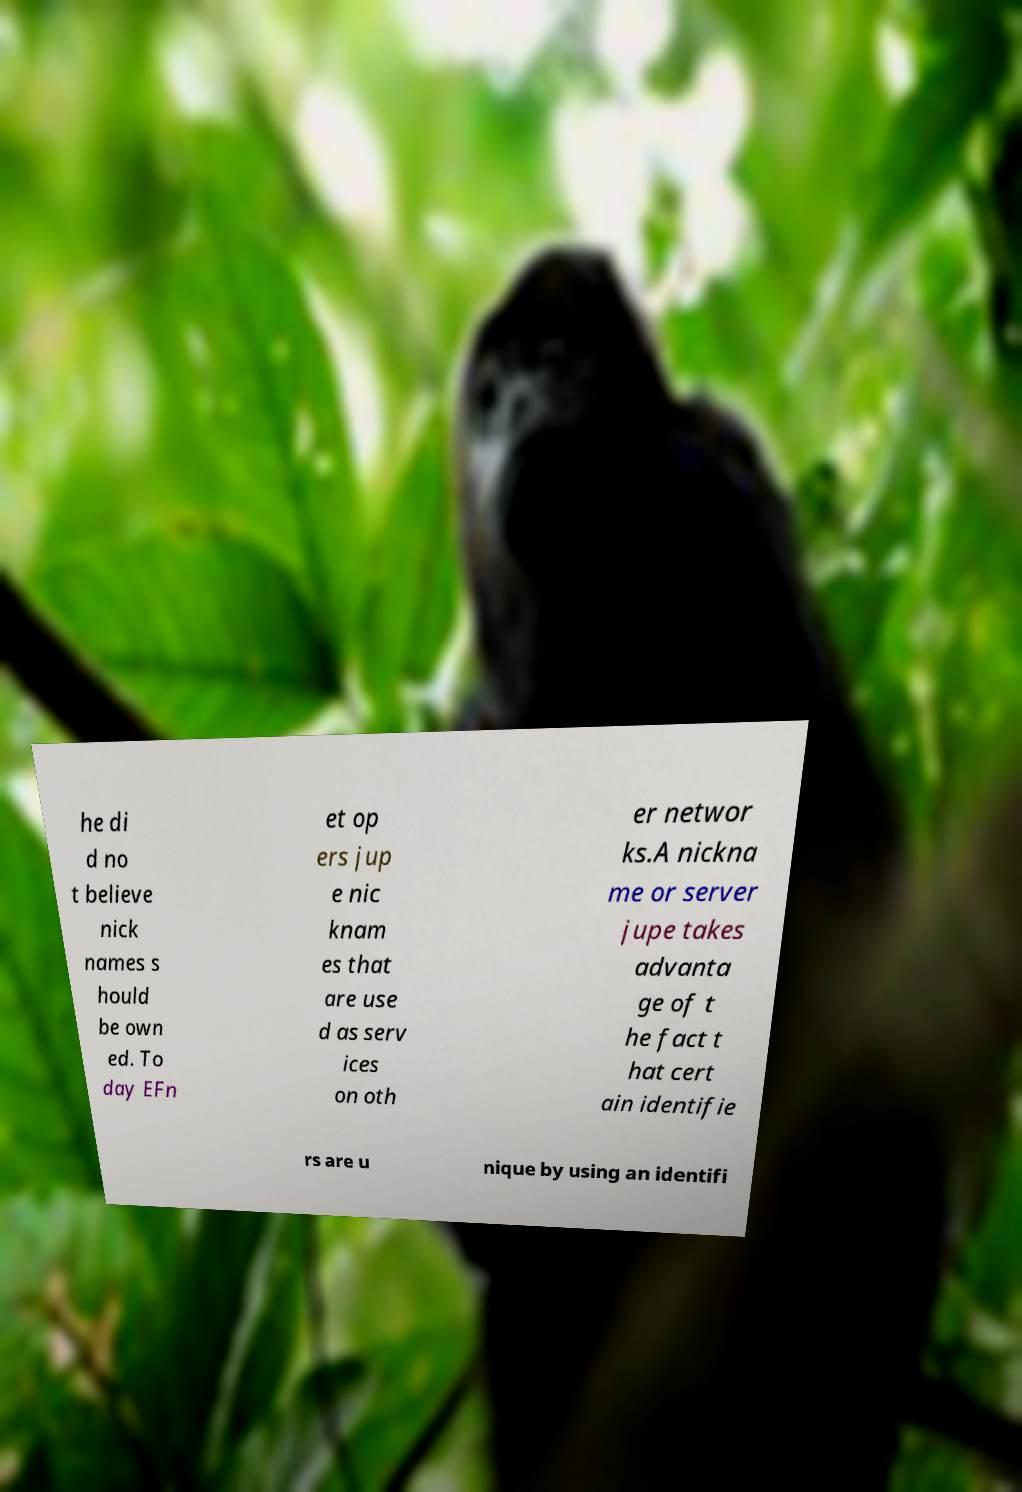I need the written content from this picture converted into text. Can you do that? he di d no t believe nick names s hould be own ed. To day EFn et op ers jup e nic knam es that are use d as serv ices on oth er networ ks.A nickna me or server jupe takes advanta ge of t he fact t hat cert ain identifie rs are u nique by using an identifi 